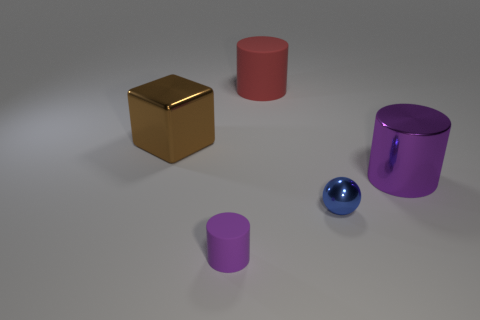Is the big cylinder on the left side of the big purple object made of the same material as the purple cylinder that is behind the small purple matte cylinder?
Provide a short and direct response. No. Is the number of purple metal cylinders that are left of the tiny cylinder less than the number of small blue metallic things?
Your response must be concise. Yes. What color is the large metallic object on the left side of the tiny matte object?
Give a very brief answer. Brown. There is a small blue sphere on the left side of the cylinder that is right of the large matte object; what is it made of?
Your answer should be very brief. Metal. Are there any yellow metal cubes of the same size as the brown metal object?
Your answer should be compact. No. How many objects are cylinders left of the tiny metallic object or objects on the right side of the blue metallic thing?
Give a very brief answer. 3. There is a purple thing behind the blue shiny object; is its size the same as the thing behind the brown cube?
Keep it short and to the point. Yes. Are there any rubber cylinders right of the cylinder left of the big red rubber cylinder?
Make the answer very short. Yes. There is a small ball; what number of blue things are to the right of it?
Offer a very short reply. 0. How many other objects are there of the same color as the big metallic cylinder?
Your answer should be very brief. 1. 